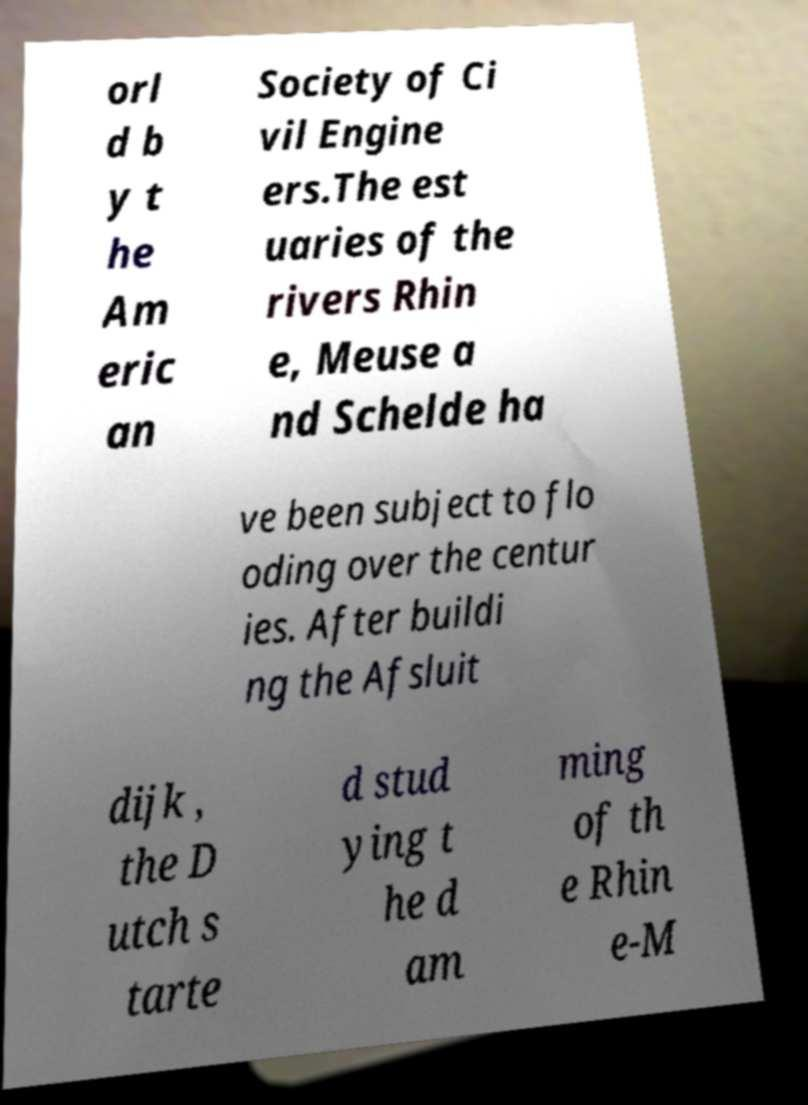Please identify and transcribe the text found in this image. orl d b y t he Am eric an Society of Ci vil Engine ers.The est uaries of the rivers Rhin e, Meuse a nd Schelde ha ve been subject to flo oding over the centur ies. After buildi ng the Afsluit dijk , the D utch s tarte d stud ying t he d am ming of th e Rhin e-M 